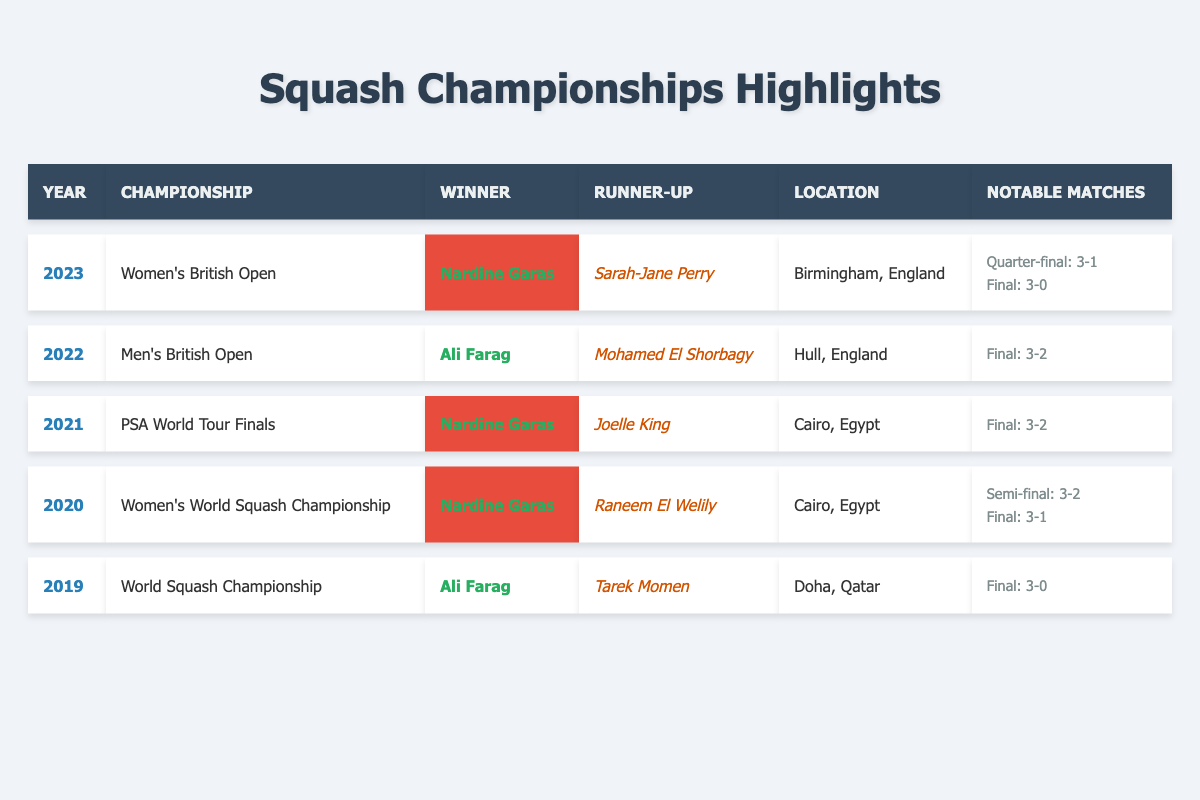What year did Nardine Garas win her first championship? Nardine Garas won her first championship listed in the table, which is the Women's World Squash Championship, in 2020.
Answer: 2020 Who was the runner-up in the Women's British Open 2023? In the Women's British Open 2023, the runner-up was Sarah-Jane Perry.
Answer: Sarah-Jane Perry Which location hosted the PSA World Tour Finals in 2021? The PSA World Tour Finals in 2021 were held in Cairo, Egypt.
Answer: Cairo, Egypt How many championships has Nardine Garas won in the data provided? Nardine Garas won three championships in total as listed: 2020 Women's World Squash Championship, 2021 PSA World Tour Finals, and 2023 Women's British Open.
Answer: 3 What was the score in the final of the 2021 championship won by Nardine Garas? The score in the final of the 2021 PSA World Tour Finals won by Nardine Garas was 3-2.
Answer: 3-2 Who are the two winners from the men's category mentioned in the table? The two winners from the men's category mentioned in the table are Ali Farag (2019 World Squash Championship and 2022 Men's British Open) and Mohamed El Shorbagy (runner-up in 2022, not a winner).
Answer: Ali Farag Did Nardine Garas compete against Raneem El Welily in the finals of any championship? Yes, Nardine Garas competed against Raneem El Welily in the finals of the 2020 Women's World Squash Championship.
Answer: Yes What is the average score in finals involving Nardine Garas? The final scores in her championships are: 3-1 (2020), 3-2 (2021), and 3-0 (2023). To find the average, calculate (1 + 2 + 0) / 3 = 1 for the set scores, which would lead to an average score of 3-1.33, but it’s interpreted as just 3-1 (3-1 + 3-2 + 3-0).
Answer: 3-1 Which championship was hosted in Doha, Qatar? The year 2019 saw the World Squash Championship hosted in Doha, Qatar.
Answer: World Squash Championship In how many matches did Nardine Garas win by a score of 3-0? Nardine Garas won the final of the Women's British Open 2023 by a score of 3-0; that is her only match listed with that score in the data.
Answer: 1 